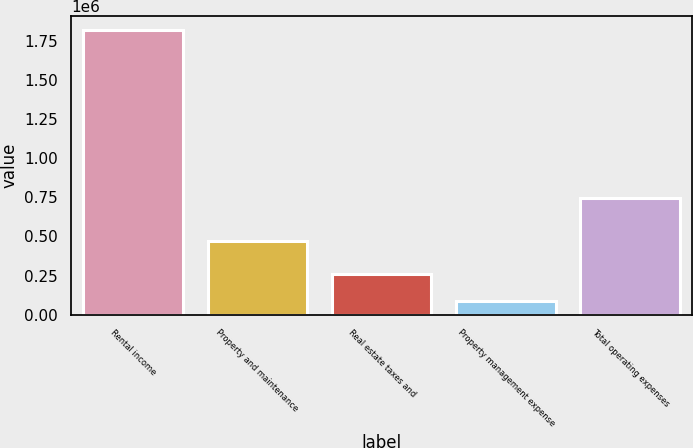Convert chart to OTSL. <chart><loc_0><loc_0><loc_500><loc_500><bar_chart><fcel>Rental income<fcel>Property and maintenance<fcel>Real estate taxes and<fcel>Property management expense<fcel>Total operating expenses<nl><fcel>1.81486e+06<fcel>472899<fcel>260215<fcel>87476<fcel>742262<nl></chart> 